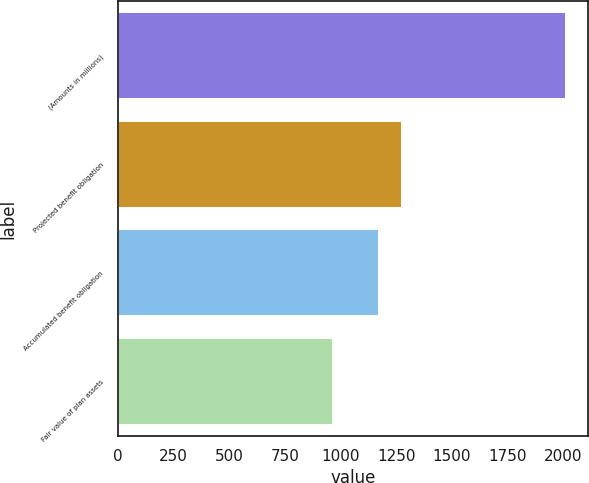<chart> <loc_0><loc_0><loc_500><loc_500><bar_chart><fcel>(Amounts in millions)<fcel>Projected benefit obligation<fcel>Accumulated benefit obligation<fcel>Fair value of plan assets<nl><fcel>2012<fcel>1275.4<fcel>1170.6<fcel>964<nl></chart> 